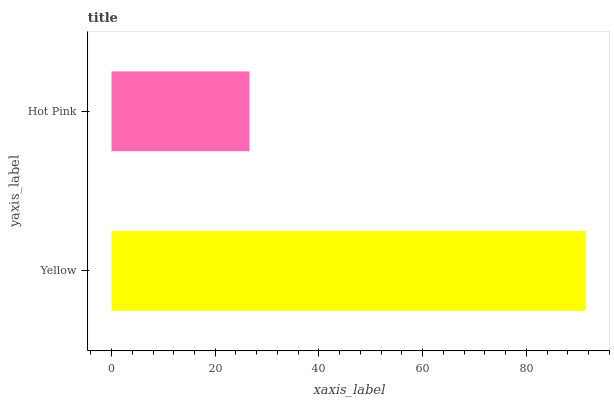Is Hot Pink the minimum?
Answer yes or no. Yes. Is Yellow the maximum?
Answer yes or no. Yes. Is Hot Pink the maximum?
Answer yes or no. No. Is Yellow greater than Hot Pink?
Answer yes or no. Yes. Is Hot Pink less than Yellow?
Answer yes or no. Yes. Is Hot Pink greater than Yellow?
Answer yes or no. No. Is Yellow less than Hot Pink?
Answer yes or no. No. Is Yellow the high median?
Answer yes or no. Yes. Is Hot Pink the low median?
Answer yes or no. Yes. Is Hot Pink the high median?
Answer yes or no. No. Is Yellow the low median?
Answer yes or no. No. 